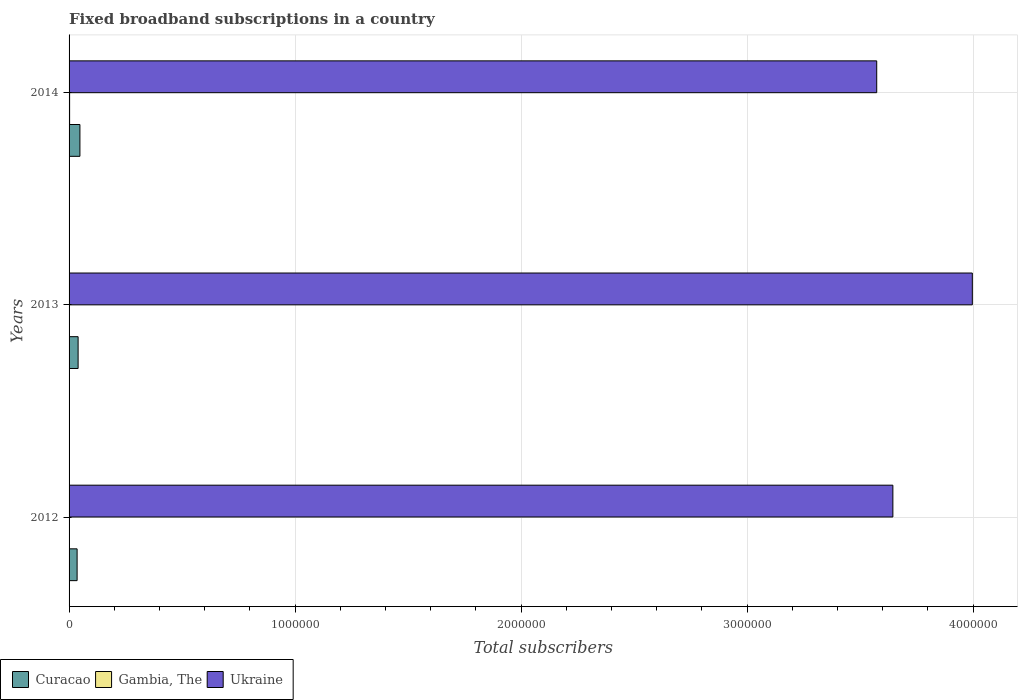How many groups of bars are there?
Keep it short and to the point. 3. Are the number of bars on each tick of the Y-axis equal?
Give a very brief answer. Yes. How many bars are there on the 1st tick from the bottom?
Your answer should be compact. 3. What is the label of the 1st group of bars from the top?
Provide a short and direct response. 2014. What is the number of broadband subscriptions in Curacao in 2012?
Offer a terse response. 3.56e+04. Across all years, what is the maximum number of broadband subscriptions in Gambia, The?
Provide a short and direct response. 2382. Across all years, what is the minimum number of broadband subscriptions in Gambia, The?
Give a very brief answer. 438. In which year was the number of broadband subscriptions in Curacao maximum?
Give a very brief answer. 2014. In which year was the number of broadband subscriptions in Curacao minimum?
Your response must be concise. 2012. What is the total number of broadband subscriptions in Curacao in the graph?
Ensure brevity in your answer.  1.24e+05. What is the difference between the number of broadband subscriptions in Ukraine in 2013 and that in 2014?
Provide a short and direct response. 4.23e+05. What is the difference between the number of broadband subscriptions in Ukraine in 2014 and the number of broadband subscriptions in Curacao in 2012?
Ensure brevity in your answer.  3.54e+06. What is the average number of broadband subscriptions in Curacao per year?
Make the answer very short. 4.12e+04. In the year 2014, what is the difference between the number of broadband subscriptions in Curacao and number of broadband subscriptions in Gambia, The?
Make the answer very short. 4.56e+04. In how many years, is the number of broadband subscriptions in Gambia, The greater than 1000000 ?
Offer a terse response. 0. What is the ratio of the number of broadband subscriptions in Curacao in 2012 to that in 2013?
Give a very brief answer. 0.89. Is the number of broadband subscriptions in Ukraine in 2012 less than that in 2013?
Offer a very short reply. Yes. What is the difference between the highest and the second highest number of broadband subscriptions in Ukraine?
Give a very brief answer. 3.52e+05. What is the difference between the highest and the lowest number of broadband subscriptions in Curacao?
Ensure brevity in your answer.  1.24e+04. In how many years, is the number of broadband subscriptions in Curacao greater than the average number of broadband subscriptions in Curacao taken over all years?
Your response must be concise. 1. Is the sum of the number of broadband subscriptions in Ukraine in 2013 and 2014 greater than the maximum number of broadband subscriptions in Curacao across all years?
Ensure brevity in your answer.  Yes. What does the 3rd bar from the top in 2013 represents?
Provide a short and direct response. Curacao. What does the 1st bar from the bottom in 2013 represents?
Provide a short and direct response. Curacao. Is it the case that in every year, the sum of the number of broadband subscriptions in Gambia, The and number of broadband subscriptions in Curacao is greater than the number of broadband subscriptions in Ukraine?
Provide a succinct answer. No. Are all the bars in the graph horizontal?
Give a very brief answer. Yes. Does the graph contain grids?
Provide a succinct answer. Yes. How are the legend labels stacked?
Give a very brief answer. Horizontal. What is the title of the graph?
Your response must be concise. Fixed broadband subscriptions in a country. Does "Gabon" appear as one of the legend labels in the graph?
Give a very brief answer. No. What is the label or title of the X-axis?
Keep it short and to the point. Total subscribers. What is the Total subscribers in Curacao in 2012?
Offer a terse response. 3.56e+04. What is the Total subscribers in Ukraine in 2012?
Your response must be concise. 3.64e+06. What is the Total subscribers in Curacao in 2013?
Your answer should be very brief. 4.00e+04. What is the Total subscribers of Gambia, The in 2013?
Your response must be concise. 438. What is the Total subscribers in Ukraine in 2013?
Your answer should be compact. 4.00e+06. What is the Total subscribers in Curacao in 2014?
Your response must be concise. 4.80e+04. What is the Total subscribers of Gambia, The in 2014?
Keep it short and to the point. 2382. What is the Total subscribers of Ukraine in 2014?
Ensure brevity in your answer.  3.57e+06. Across all years, what is the maximum Total subscribers of Curacao?
Keep it short and to the point. 4.80e+04. Across all years, what is the maximum Total subscribers of Gambia, The?
Your response must be concise. 2382. Across all years, what is the maximum Total subscribers of Ukraine?
Keep it short and to the point. 4.00e+06. Across all years, what is the minimum Total subscribers in Curacao?
Provide a short and direct response. 3.56e+04. Across all years, what is the minimum Total subscribers of Gambia, The?
Offer a very short reply. 438. Across all years, what is the minimum Total subscribers of Ukraine?
Your answer should be very brief. 3.57e+06. What is the total Total subscribers in Curacao in the graph?
Provide a short and direct response. 1.24e+05. What is the total Total subscribers of Gambia, The in the graph?
Give a very brief answer. 3320. What is the total Total subscribers of Ukraine in the graph?
Keep it short and to the point. 1.12e+07. What is the difference between the Total subscribers of Curacao in 2012 and that in 2013?
Your answer should be very brief. -4418. What is the difference between the Total subscribers of Ukraine in 2012 and that in 2013?
Make the answer very short. -3.52e+05. What is the difference between the Total subscribers in Curacao in 2012 and that in 2014?
Ensure brevity in your answer.  -1.24e+04. What is the difference between the Total subscribers in Gambia, The in 2012 and that in 2014?
Your response must be concise. -1882. What is the difference between the Total subscribers of Ukraine in 2012 and that in 2014?
Provide a short and direct response. 7.15e+04. What is the difference between the Total subscribers of Curacao in 2013 and that in 2014?
Make the answer very short. -8000. What is the difference between the Total subscribers of Gambia, The in 2013 and that in 2014?
Your response must be concise. -1944. What is the difference between the Total subscribers of Ukraine in 2013 and that in 2014?
Keep it short and to the point. 4.23e+05. What is the difference between the Total subscribers in Curacao in 2012 and the Total subscribers in Gambia, The in 2013?
Provide a succinct answer. 3.51e+04. What is the difference between the Total subscribers in Curacao in 2012 and the Total subscribers in Ukraine in 2013?
Provide a succinct answer. -3.96e+06. What is the difference between the Total subscribers of Gambia, The in 2012 and the Total subscribers of Ukraine in 2013?
Your answer should be compact. -4.00e+06. What is the difference between the Total subscribers in Curacao in 2012 and the Total subscribers in Gambia, The in 2014?
Provide a succinct answer. 3.32e+04. What is the difference between the Total subscribers in Curacao in 2012 and the Total subscribers in Ukraine in 2014?
Your answer should be compact. -3.54e+06. What is the difference between the Total subscribers of Gambia, The in 2012 and the Total subscribers of Ukraine in 2014?
Your answer should be compact. -3.57e+06. What is the difference between the Total subscribers in Curacao in 2013 and the Total subscribers in Gambia, The in 2014?
Ensure brevity in your answer.  3.76e+04. What is the difference between the Total subscribers of Curacao in 2013 and the Total subscribers of Ukraine in 2014?
Ensure brevity in your answer.  -3.53e+06. What is the difference between the Total subscribers in Gambia, The in 2013 and the Total subscribers in Ukraine in 2014?
Make the answer very short. -3.57e+06. What is the average Total subscribers in Curacao per year?
Make the answer very short. 4.12e+04. What is the average Total subscribers in Gambia, The per year?
Make the answer very short. 1106.67. What is the average Total subscribers in Ukraine per year?
Offer a terse response. 3.74e+06. In the year 2012, what is the difference between the Total subscribers in Curacao and Total subscribers in Gambia, The?
Ensure brevity in your answer.  3.51e+04. In the year 2012, what is the difference between the Total subscribers of Curacao and Total subscribers of Ukraine?
Provide a succinct answer. -3.61e+06. In the year 2012, what is the difference between the Total subscribers of Gambia, The and Total subscribers of Ukraine?
Provide a succinct answer. -3.64e+06. In the year 2013, what is the difference between the Total subscribers in Curacao and Total subscribers in Gambia, The?
Your answer should be compact. 3.96e+04. In the year 2013, what is the difference between the Total subscribers in Curacao and Total subscribers in Ukraine?
Your answer should be compact. -3.96e+06. In the year 2013, what is the difference between the Total subscribers in Gambia, The and Total subscribers in Ukraine?
Your response must be concise. -4.00e+06. In the year 2014, what is the difference between the Total subscribers in Curacao and Total subscribers in Gambia, The?
Give a very brief answer. 4.56e+04. In the year 2014, what is the difference between the Total subscribers in Curacao and Total subscribers in Ukraine?
Make the answer very short. -3.53e+06. In the year 2014, what is the difference between the Total subscribers in Gambia, The and Total subscribers in Ukraine?
Make the answer very short. -3.57e+06. What is the ratio of the Total subscribers in Curacao in 2012 to that in 2013?
Your answer should be compact. 0.89. What is the ratio of the Total subscribers in Gambia, The in 2012 to that in 2013?
Ensure brevity in your answer.  1.14. What is the ratio of the Total subscribers in Ukraine in 2012 to that in 2013?
Your response must be concise. 0.91. What is the ratio of the Total subscribers in Curacao in 2012 to that in 2014?
Offer a terse response. 0.74. What is the ratio of the Total subscribers of Gambia, The in 2012 to that in 2014?
Your answer should be very brief. 0.21. What is the ratio of the Total subscribers in Ukraine in 2012 to that in 2014?
Your answer should be very brief. 1.02. What is the ratio of the Total subscribers of Gambia, The in 2013 to that in 2014?
Provide a succinct answer. 0.18. What is the ratio of the Total subscribers in Ukraine in 2013 to that in 2014?
Offer a terse response. 1.12. What is the difference between the highest and the second highest Total subscribers of Curacao?
Keep it short and to the point. 8000. What is the difference between the highest and the second highest Total subscribers in Gambia, The?
Provide a succinct answer. 1882. What is the difference between the highest and the second highest Total subscribers of Ukraine?
Offer a very short reply. 3.52e+05. What is the difference between the highest and the lowest Total subscribers in Curacao?
Your answer should be compact. 1.24e+04. What is the difference between the highest and the lowest Total subscribers in Gambia, The?
Make the answer very short. 1944. What is the difference between the highest and the lowest Total subscribers of Ukraine?
Offer a terse response. 4.23e+05. 